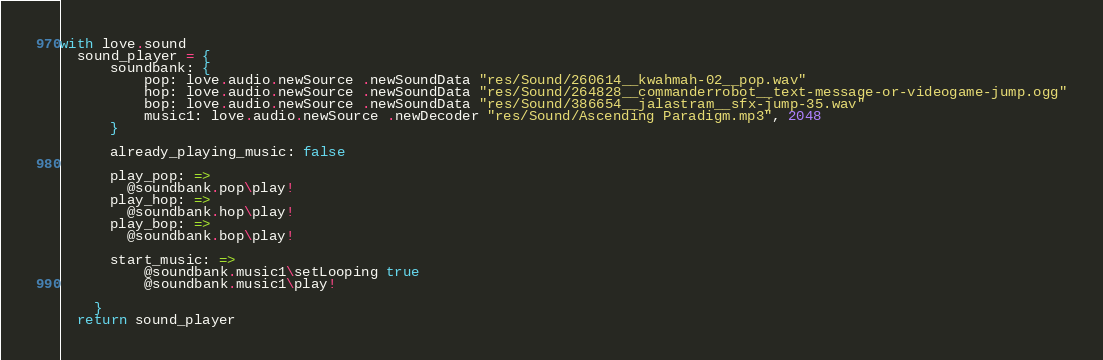Convert code to text. <code><loc_0><loc_0><loc_500><loc_500><_MoonScript_>with love.sound
  sound_player = {
      soundbank: {
          pop: love.audio.newSource .newSoundData "res/Sound/260614__kwahmah-02__pop.wav"
          hop: love.audio.newSource .newSoundData "res/Sound/264828__commanderrobot__text-message-or-videogame-jump.ogg"
          bop: love.audio.newSource .newSoundData "res/Sound/386654__jalastram__sfx-jump-35.wav" 
          music1: love.audio.newSource .newDecoder "res/Sound/Ascending Paradigm.mp3", 2048
      }

      already_playing_music: false

      play_pop: =>
        @soundbank.pop\play!
      play_hop: =>
        @soundbank.hop\play!
      play_bop: =>
        @soundbank.bop\play!

      start_music: =>
          @soundbank.music1\setLooping true 
          @soundbank.music1\play!
      
    }
  return sound_player</code> 